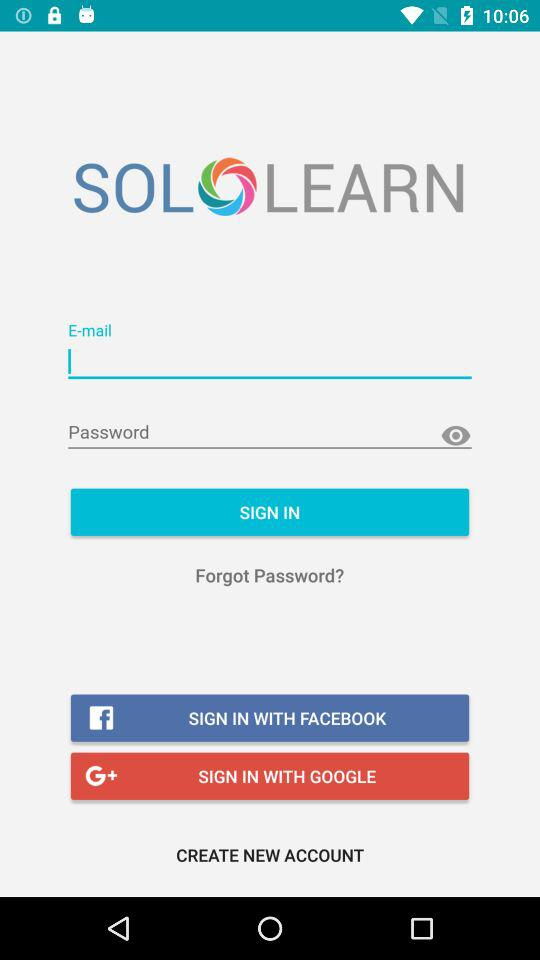What is the name of the application? The name of the application is "SOLOLEARN". 